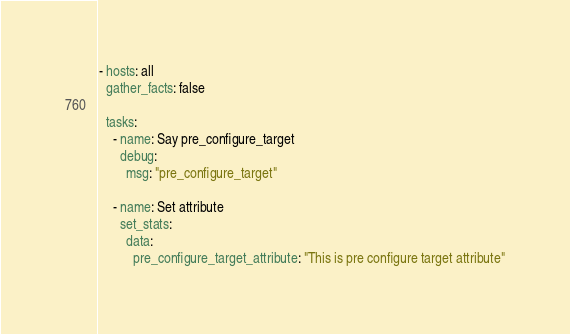<code> <loc_0><loc_0><loc_500><loc_500><_YAML_>- hosts: all
  gather_facts: false

  tasks:
    - name: Say pre_configure_target
      debug:
        msg: "pre_configure_target"

    - name: Set attribute
      set_stats:
        data:
          pre_configure_target_attribute: "This is pre configure target attribute"
</code> 